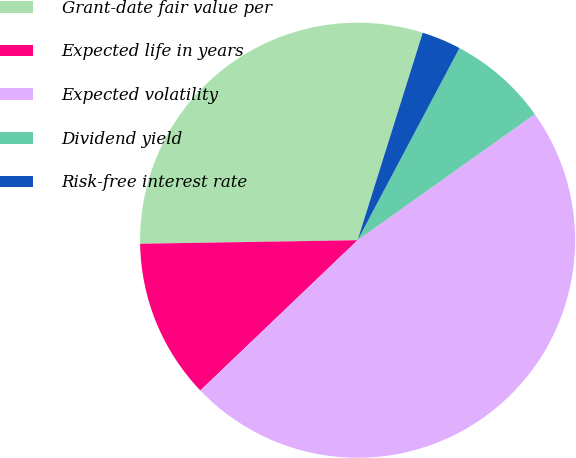<chart> <loc_0><loc_0><loc_500><loc_500><pie_chart><fcel>Grant-date fair value per<fcel>Expected life in years<fcel>Expected volatility<fcel>Dividend yield<fcel>Risk-free interest rate<nl><fcel>30.1%<fcel>11.88%<fcel>47.7%<fcel>7.4%<fcel>2.92%<nl></chart> 